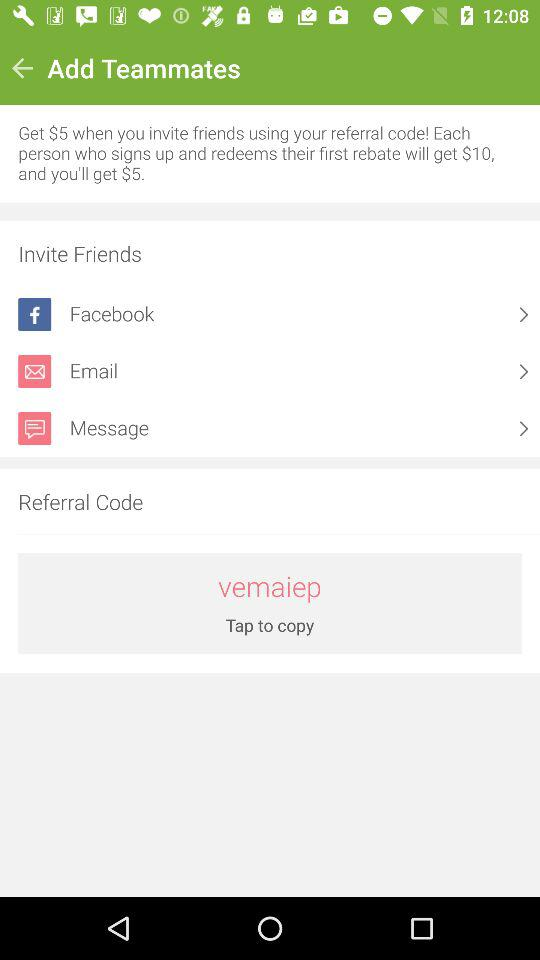Through which options can the friends be invited? The friends can be invited through "Facebook", "Email" and "Message". 